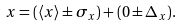Convert formula to latex. <formula><loc_0><loc_0><loc_500><loc_500>x = ( \langle x \rangle \pm \sigma _ { x } ) + ( 0 \pm \Delta _ { x } ) .</formula> 